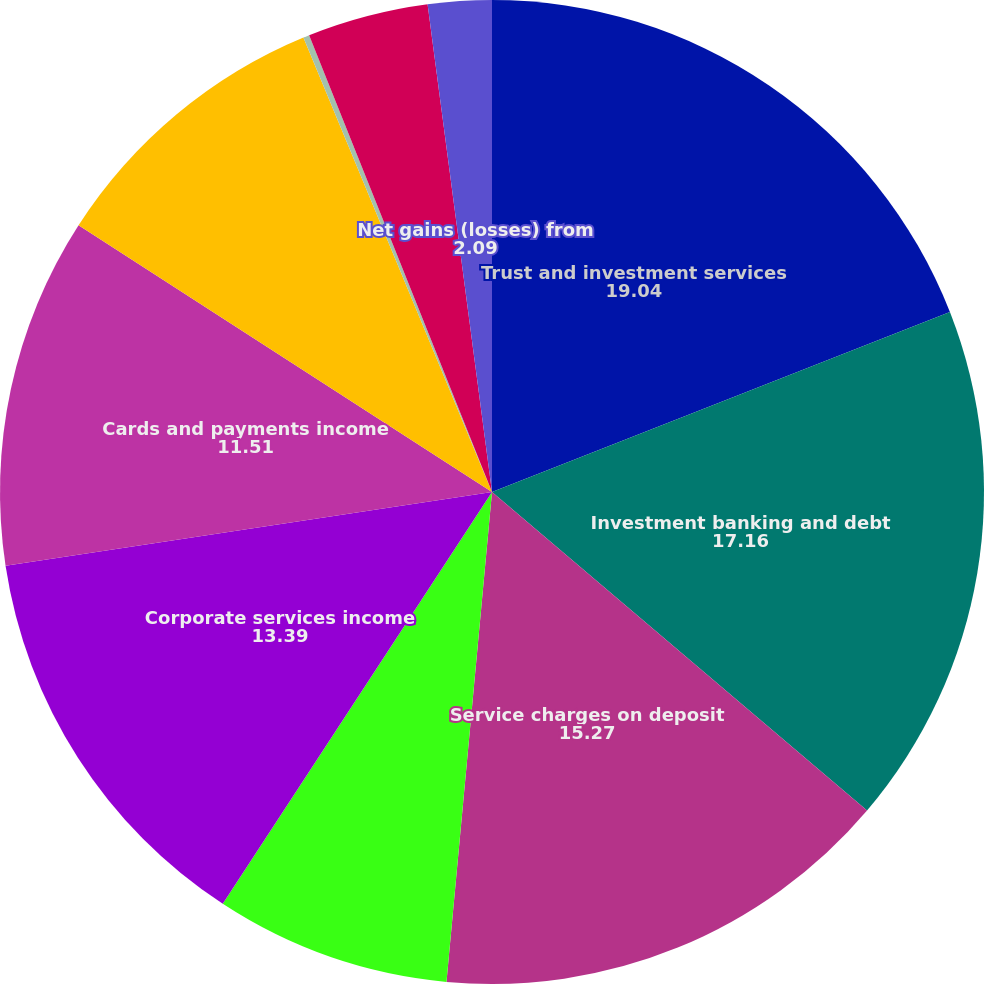Convert chart to OTSL. <chart><loc_0><loc_0><loc_500><loc_500><pie_chart><fcel>Trust and investment services<fcel>Investment banking and debt<fcel>Service charges on deposit<fcel>Operating lease income and<fcel>Corporate services income<fcel>Cards and payments income<fcel>Corporate-owned life insurance<fcel>Consumer mortgage income<fcel>Mortgage servicing fees<fcel>Net gains (losses) from<nl><fcel>19.04%<fcel>17.16%<fcel>15.27%<fcel>7.74%<fcel>13.39%<fcel>11.51%<fcel>9.62%<fcel>0.2%<fcel>3.97%<fcel>2.09%<nl></chart> 